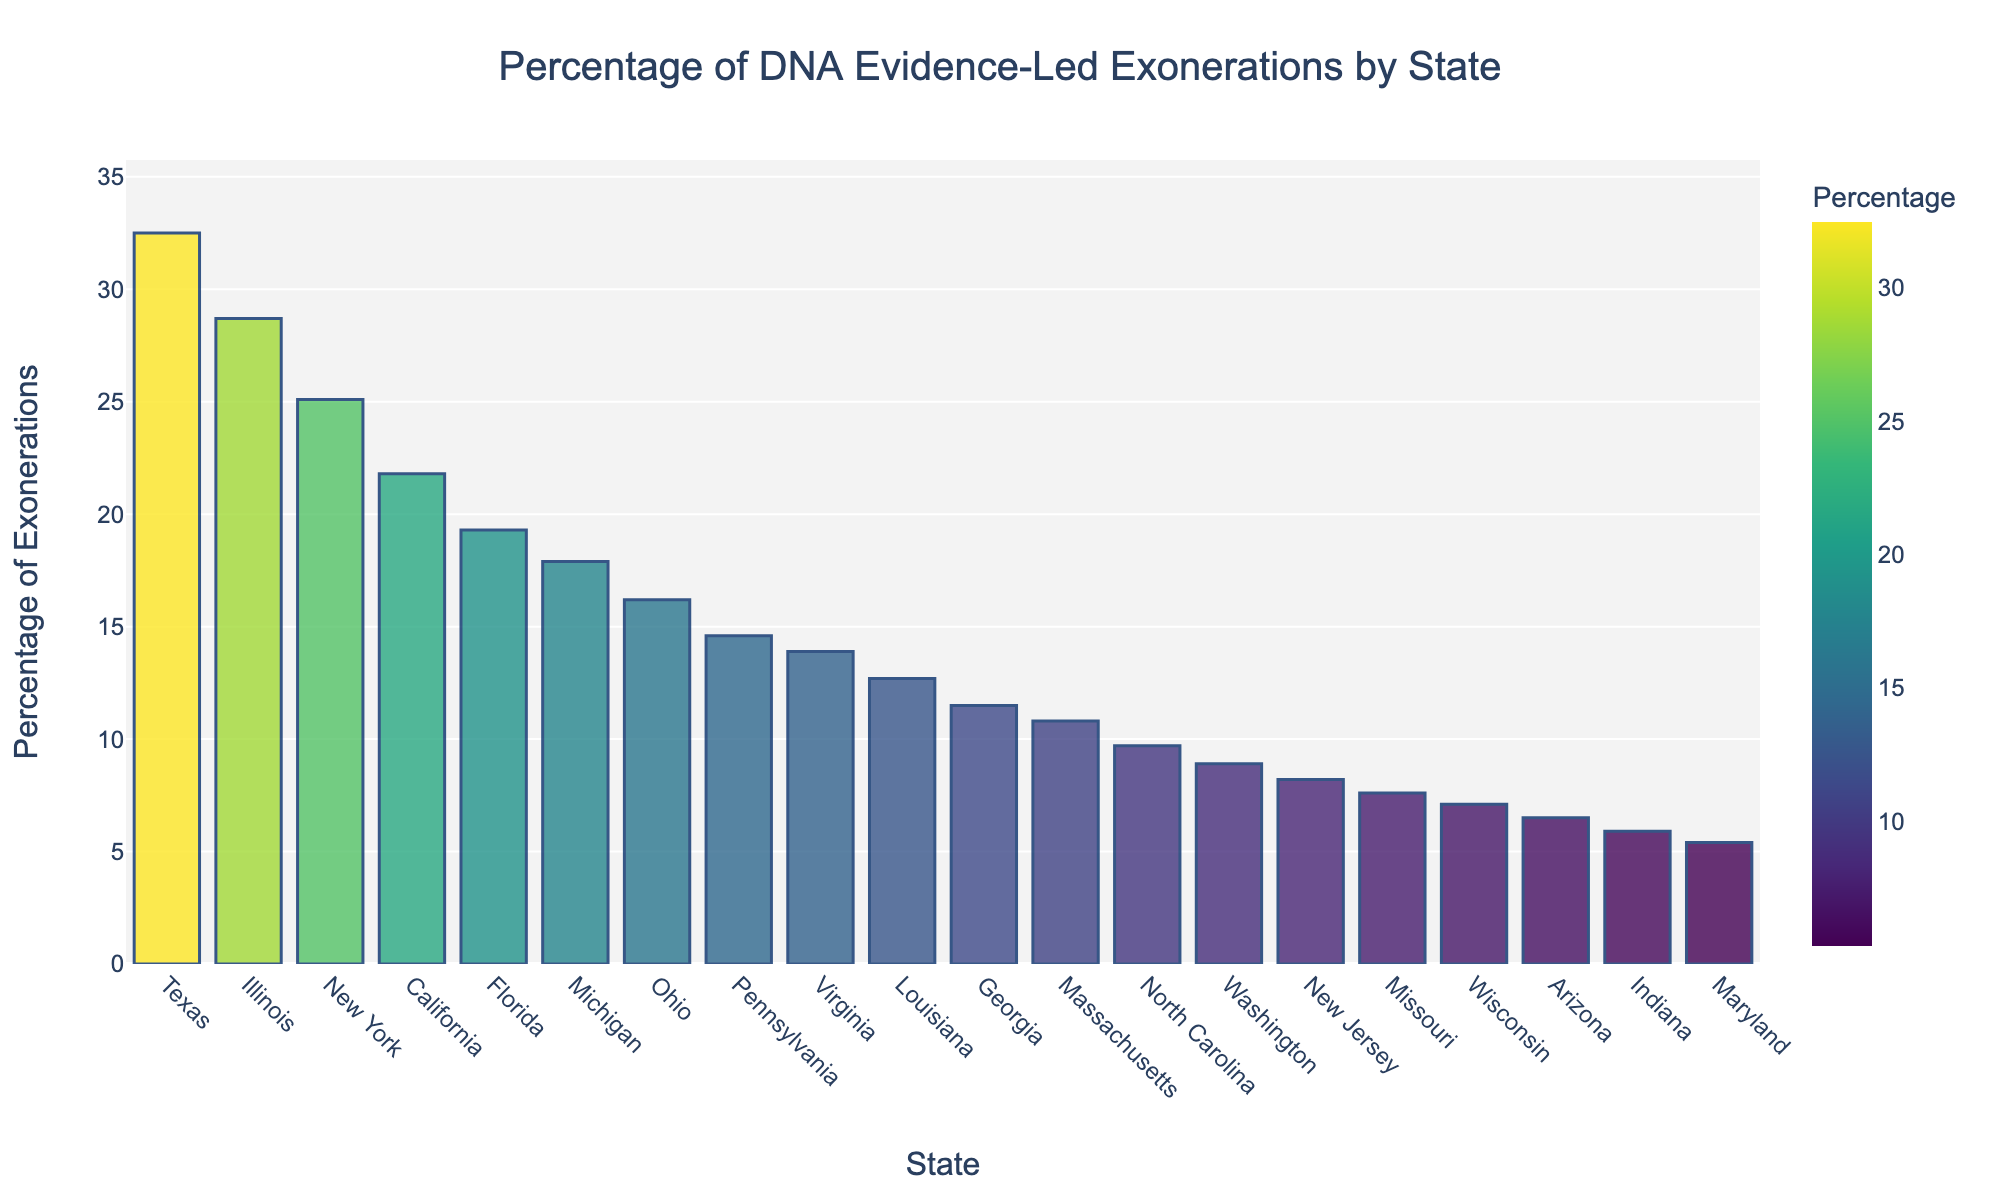Which state has the highest percentage of DNA evidence-led exonerations? By observing the heights of the bars, the highest bar represents Texas with 32.5%.
Answer: Texas Which state has the lowest percentage of DNA evidence-led exonerations? The shortest bar represents Maryland with 5.4%.
Answer: Maryland How much higher is Texas's percentage compared to Florida's percentage of DNA evidence-led exonerations? Texas has 32.5% and Florida has 19.3%. Subtract Florida’s percentage from Texas’s percentage: 32.5% - 19.3% = 13.2%.
Answer: 13.2% List the states with more than 20% of DNA evidence-led exonerations. Observe the bars and identify those higher than 20%. These states are Texas (32.5%), Illinois (28.7%), New York (25.1%), and California (21.8%).
Answer: Texas, Illinois, New York, California What is the average percentage of DNA evidence-led exonerations for the states listed? Sum the percentages and divide by the number of states. Total sum is 312.6% for 20 states: 312.6 / 20 = 15.63%.
Answer: 15.63% Which states have a percentage of DNA evidence-led exonerations less than 10%? Identify states with bars shorter than the 10% mark. These states are North Carolina (9.7%), Washington (8.9%), New Jersey (8.2%), Missouri (7.6%), Wisconsin (7.1%), Arizona (6.5%), Indiana (5.9%), and Maryland (5.4%).
Answer: North Carolina, Washington, New Jersey, Missouri, Wisconsin, Arizona, Indiana, Maryland How does the percentage of DNA evidence-led exonerations in Ohio compare to Virginia? Ohio has 16.2% and Virginia has 13.9%. Ohio’s percentage is higher.
Answer: Ohio Rank the top three states in terms of DNA evidence-led exonerations percentages. Observe the heights of the bars. Texas (32.5%), Illinois (28.7%), and New York (25.1%) have the highest percentages.
Answer: Texas, Illinois, New York What is the range of the DNA evidence-led exonerations percentage? Subtract the lowest percentage (Maryland with 5.4%) from the highest percentage (Texas with 32.5%): 32.5% - 5.4% = 27.1%.
Answer: 27.1% How do the percentages of DNA evidence-led exonerations in Michigan and Pennsylvania compare? Michigan has 17.9% and Pennsylvania has 14.6%. Michigan’s percentage is higher.
Answer: Michigan 